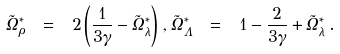Convert formula to latex. <formula><loc_0><loc_0><loc_500><loc_500>\tilde { \Omega } ^ { \ast } _ { \rho } \ = \ 2 \left ( \frac { 1 } { 3 \gamma } - \tilde { \Omega } ^ { \ast } _ { \lambda } \right ) \, , \tilde { \Omega } ^ { \ast } _ { \Lambda } \ = \ 1 - \frac { 2 } { 3 \gamma } + \tilde { \Omega } ^ { \ast } _ { \lambda } \, .</formula> 